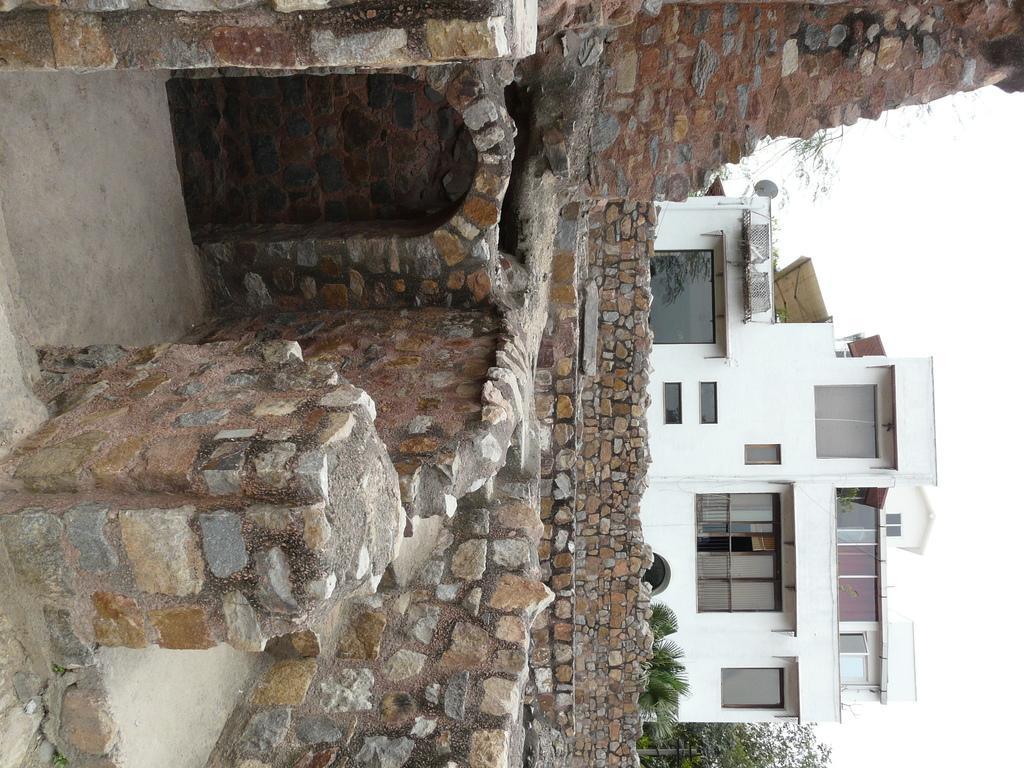Could you give a brief overview of what you see in this image? In the center of the image there is a stone structure. In the background of the image there is a building. 